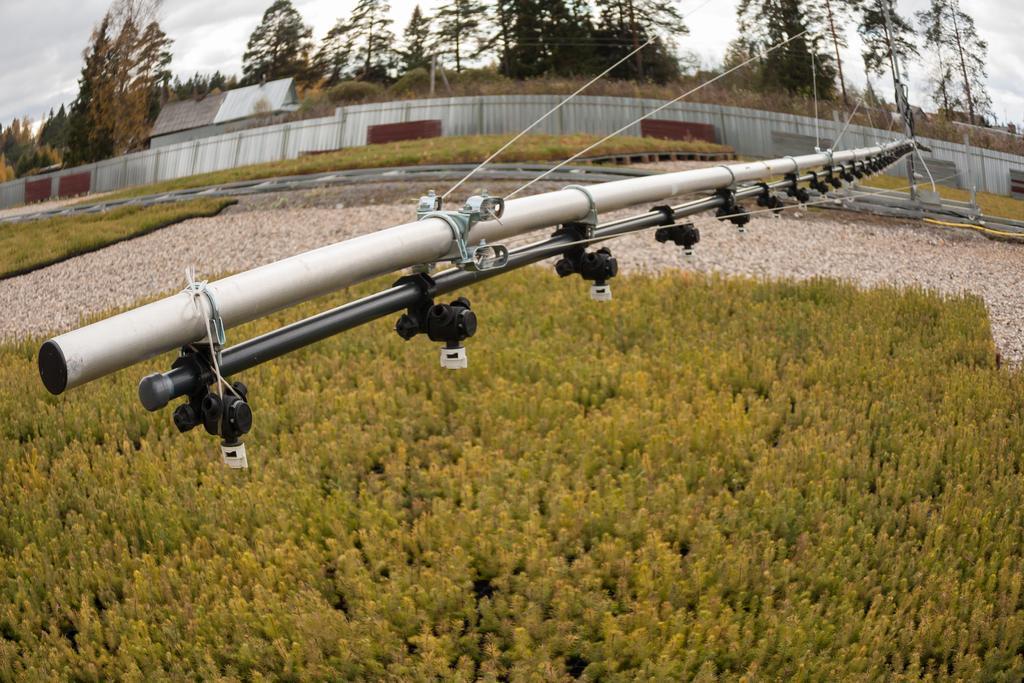Please provide a concise description of this image. In this image there are some plants, trees, house and the wall, also we can see an object, which looks like a pipe, in the background, we can see the sky. 